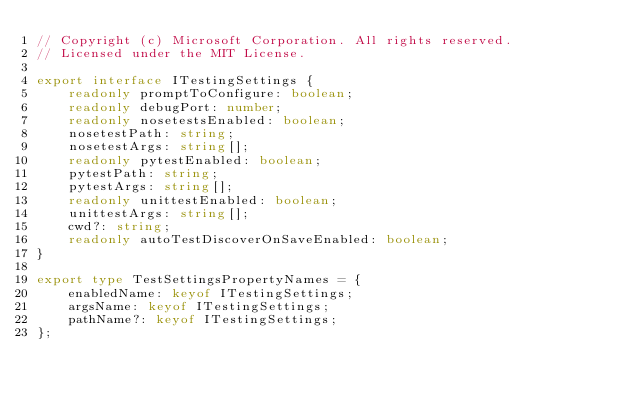Convert code to text. <code><loc_0><loc_0><loc_500><loc_500><_TypeScript_>// Copyright (c) Microsoft Corporation. All rights reserved.
// Licensed under the MIT License.

export interface ITestingSettings {
    readonly promptToConfigure: boolean;
    readonly debugPort: number;
    readonly nosetestsEnabled: boolean;
    nosetestPath: string;
    nosetestArgs: string[];
    readonly pytestEnabled: boolean;
    pytestPath: string;
    pytestArgs: string[];
    readonly unittestEnabled: boolean;
    unittestArgs: string[];
    cwd?: string;
    readonly autoTestDiscoverOnSaveEnabled: boolean;
}

export type TestSettingsPropertyNames = {
    enabledName: keyof ITestingSettings;
    argsName: keyof ITestingSettings;
    pathName?: keyof ITestingSettings;
};
</code> 